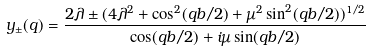Convert formula to latex. <formula><loc_0><loc_0><loc_500><loc_500>y _ { \pm } ( q ) = \frac { 2 \lambda \pm ( 4 { \lambda } ^ { 2 } + \cos ^ { 2 } ( q b / 2 ) + { \mu } ^ { 2 } \sin ^ { 2 } ( q b / 2 ) ) ^ { 1 / 2 } } { \cos ( q b / 2 ) + i \mu \sin ( q b / 2 ) }</formula> 